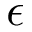Convert formula to latex. <formula><loc_0><loc_0><loc_500><loc_500>\epsilon</formula> 